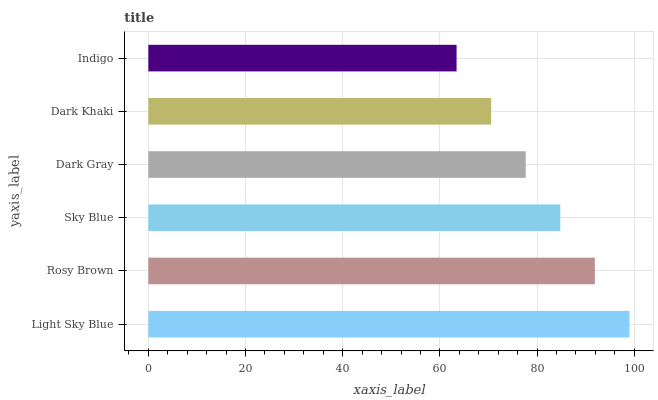Is Indigo the minimum?
Answer yes or no. Yes. Is Light Sky Blue the maximum?
Answer yes or no. Yes. Is Rosy Brown the minimum?
Answer yes or no. No. Is Rosy Brown the maximum?
Answer yes or no. No. Is Light Sky Blue greater than Rosy Brown?
Answer yes or no. Yes. Is Rosy Brown less than Light Sky Blue?
Answer yes or no. Yes. Is Rosy Brown greater than Light Sky Blue?
Answer yes or no. No. Is Light Sky Blue less than Rosy Brown?
Answer yes or no. No. Is Sky Blue the high median?
Answer yes or no. Yes. Is Dark Gray the low median?
Answer yes or no. Yes. Is Light Sky Blue the high median?
Answer yes or no. No. Is Light Sky Blue the low median?
Answer yes or no. No. 